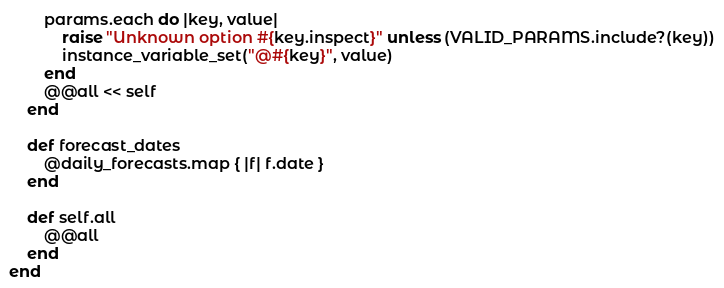Convert code to text. <code><loc_0><loc_0><loc_500><loc_500><_Ruby_>        params.each do |key, value|
            raise "Unknown option #{key.inspect}" unless (VALID_PARAMS.include?(key))
            instance_variable_set("@#{key}", value)
        end
        @@all << self
    end

    def forecast_dates
        @daily_forecasts.map { |f| f.date }
    end

    def self.all
        @@all
    end
end
</code> 